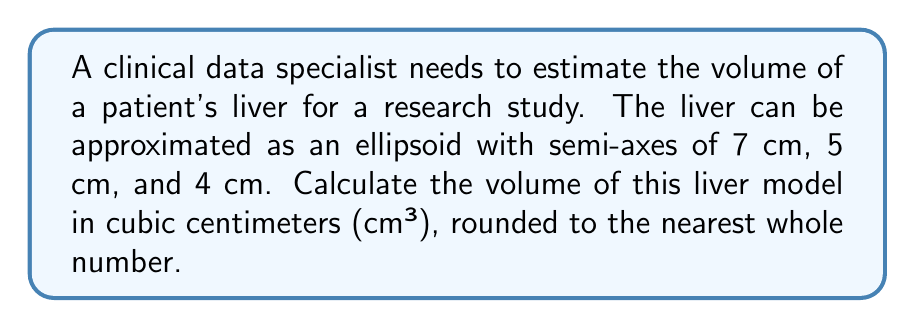What is the answer to this math problem? To solve this problem, we'll follow these steps:

1) The volume of an ellipsoid is given by the formula:

   $$V = \frac{4}{3}\pi abc$$

   Where $a$, $b$, and $c$ are the lengths of the semi-axes.

2) We're given:
   $a = 7$ cm
   $b = 5$ cm
   $c = 4$ cm

3) Let's substitute these values into our formula:

   $$V = \frac{4}{3}\pi (7)(5)(4)$$

4) Simplify inside the parentheses:

   $$V = \frac{4}{3}\pi (140)$$

5) Multiply:

   $$V = \frac{560}{3}\pi$$

6) Use 3.14159 as an approximation for $\pi$:

   $$V \approx \frac{560}{3} (3.14159)$$

7) Calculate:

   $$V \approx 586.43 \text{ cm}^3$$

8) Rounding to the nearest whole number:

   $$V \approx 586 \text{ cm}^3$$

This result provides an estimate of the liver volume based on the ellipsoid model.
Answer: 586 cm³ 